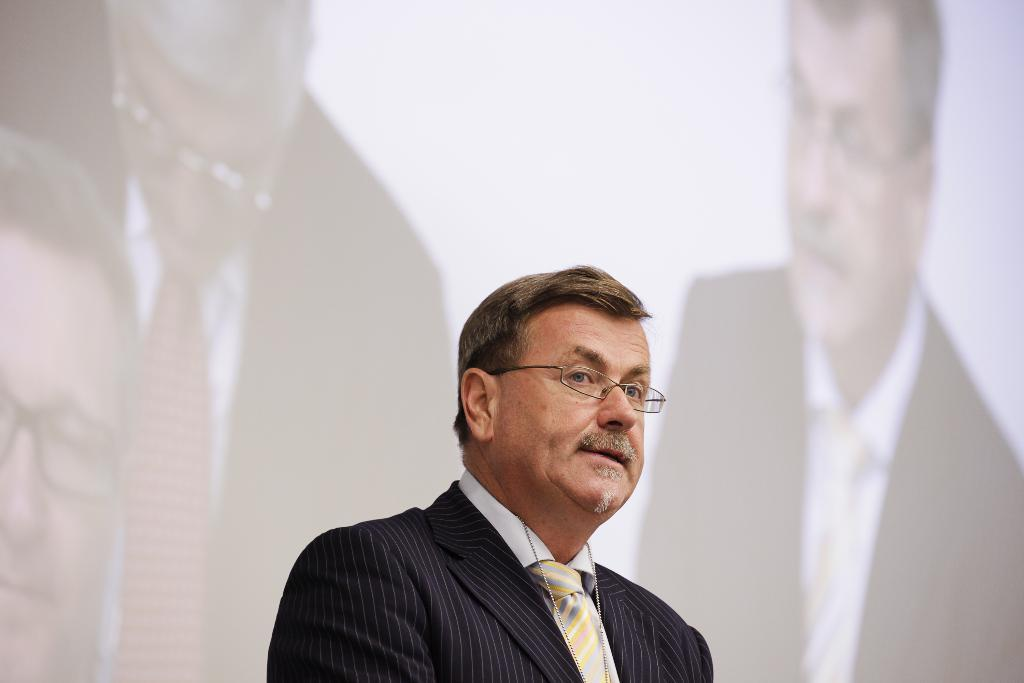What is the person in the foreground of the image wearing? The person in the foreground of the image is wearing a suit. What can be seen in the background of the image? There is a screen in the background of the image. What is displayed on the screen? People are visible on the screen. What type of comb is being used to clean up the aftermath of the event in the image? There is no comb or event present in the image; it features a person wearing a suit and a screen displaying people. 